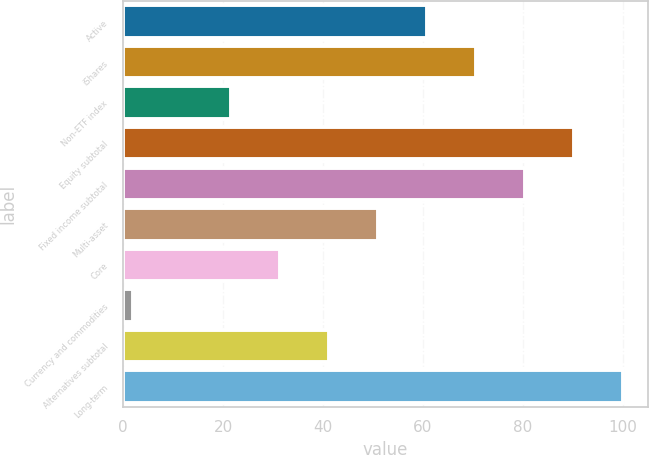<chart> <loc_0><loc_0><loc_500><loc_500><bar_chart><fcel>Active<fcel>iShares<fcel>Non-ETF index<fcel>Equity subtotal<fcel>Fixed income subtotal<fcel>Multi-asset<fcel>Core<fcel>Currency and commodities<fcel>Alternatives subtotal<fcel>Long-term<nl><fcel>60.8<fcel>70.6<fcel>21.6<fcel>90.2<fcel>80.4<fcel>51<fcel>31.4<fcel>2<fcel>41.2<fcel>100<nl></chart> 